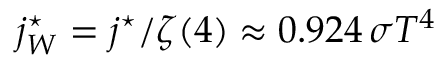Convert formula to latex. <formula><loc_0><loc_0><loc_500><loc_500>j _ { W } ^ { ^ { * } } = j ^ { ^ { * } } / \zeta ( 4 ) \approx 0 . 9 2 4 \, \sigma T ^ { 4 } \,</formula> 